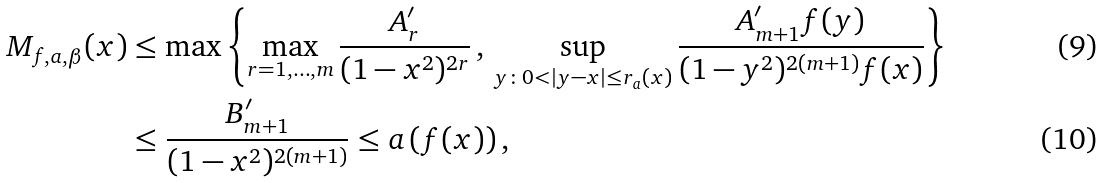<formula> <loc_0><loc_0><loc_500><loc_500>M _ { f , a , \beta } ( x ) & \leq \max \left \{ \max _ { r = 1 , \dots , m } \frac { A _ { r } ^ { \prime } } { ( 1 - x ^ { 2 } ) ^ { 2 r } } \, , \, \sup _ { y \colon 0 < | y - x | \leq r _ { a } ( x ) } \frac { A _ { m + 1 } ^ { \prime } f ( y ) } { ( 1 - y ^ { 2 } ) ^ { 2 ( m + 1 ) } f ( x ) } \right \} \\ & \leq \frac { B _ { m + 1 } ^ { \prime } } { ( 1 - x ^ { 2 } ) ^ { 2 ( m + 1 ) } } \leq a \left ( f ( x ) \right ) ,</formula> 